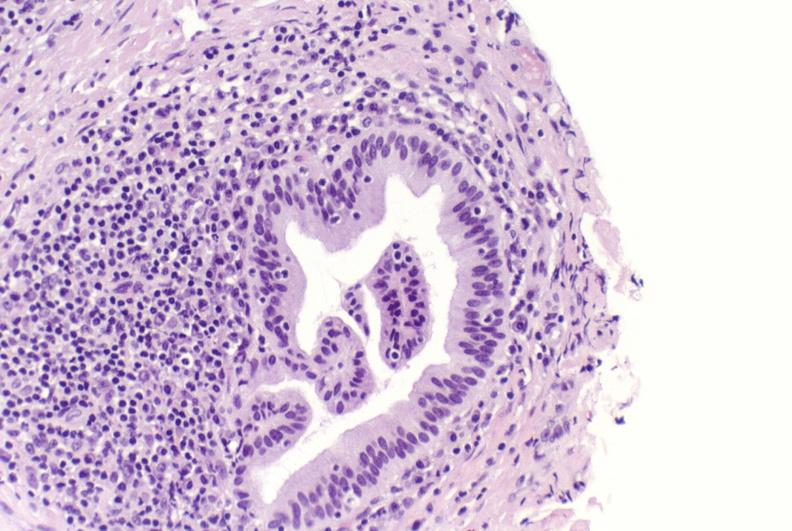does this image show primary biliary cirrhosis?
Answer the question using a single word or phrase. Yes 